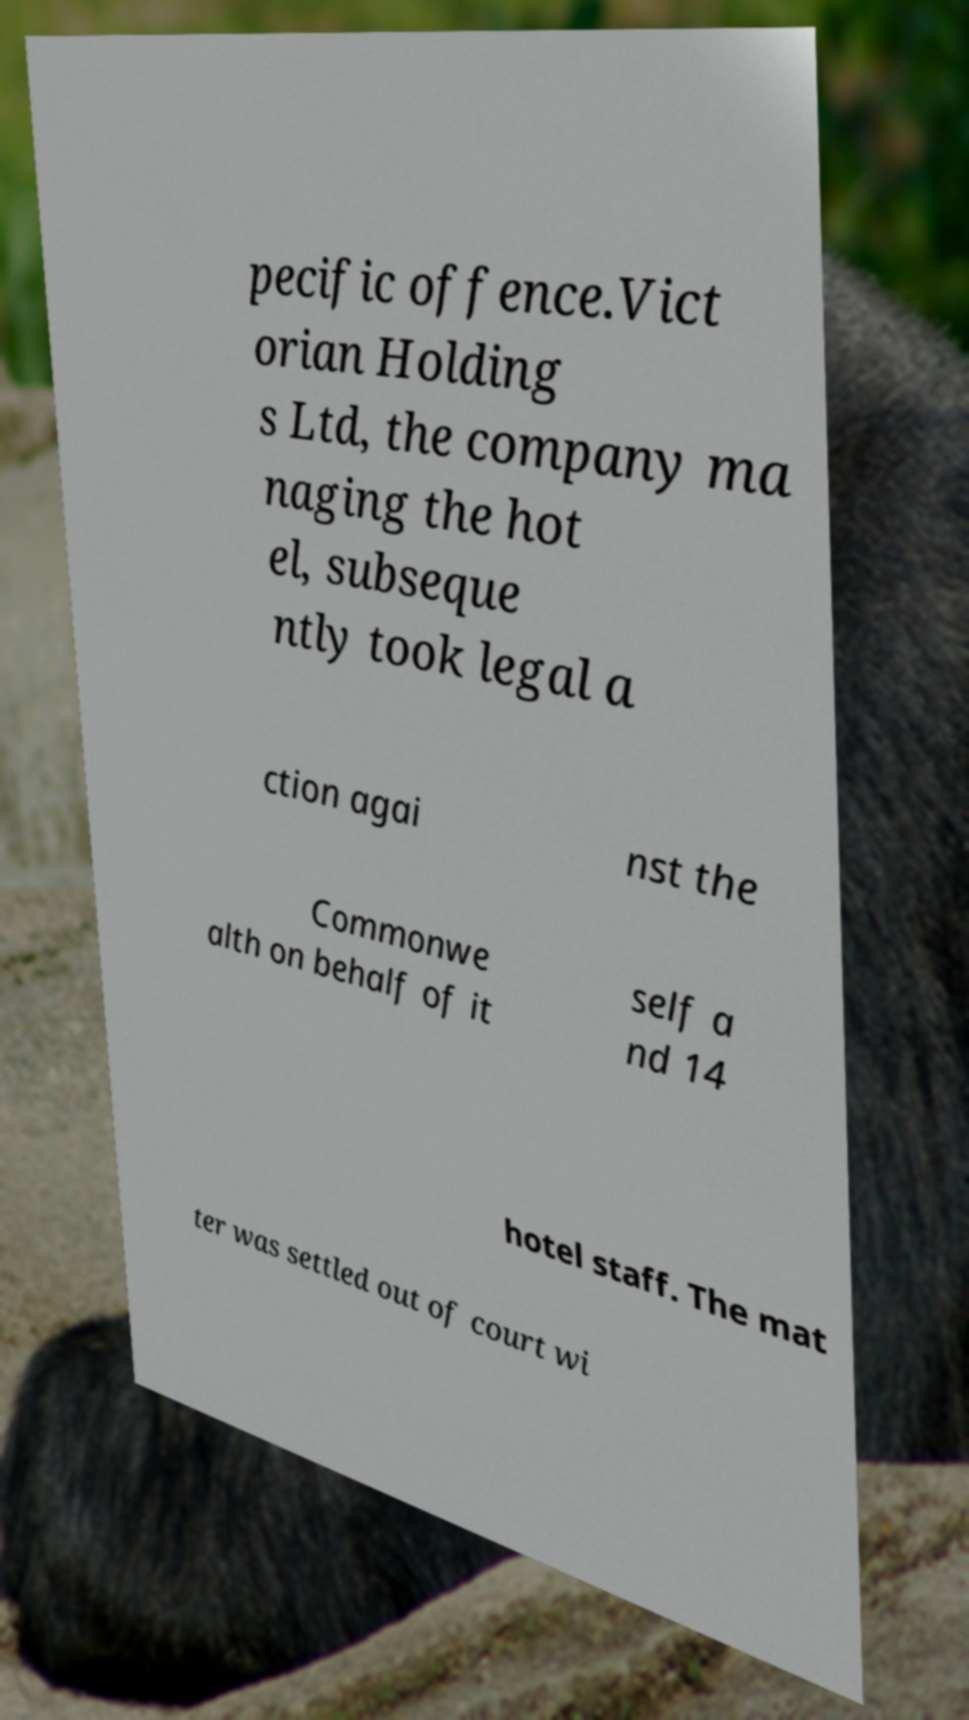There's text embedded in this image that I need extracted. Can you transcribe it verbatim? pecific offence.Vict orian Holding s Ltd, the company ma naging the hot el, subseque ntly took legal a ction agai nst the Commonwe alth on behalf of it self a nd 14 hotel staff. The mat ter was settled out of court wi 